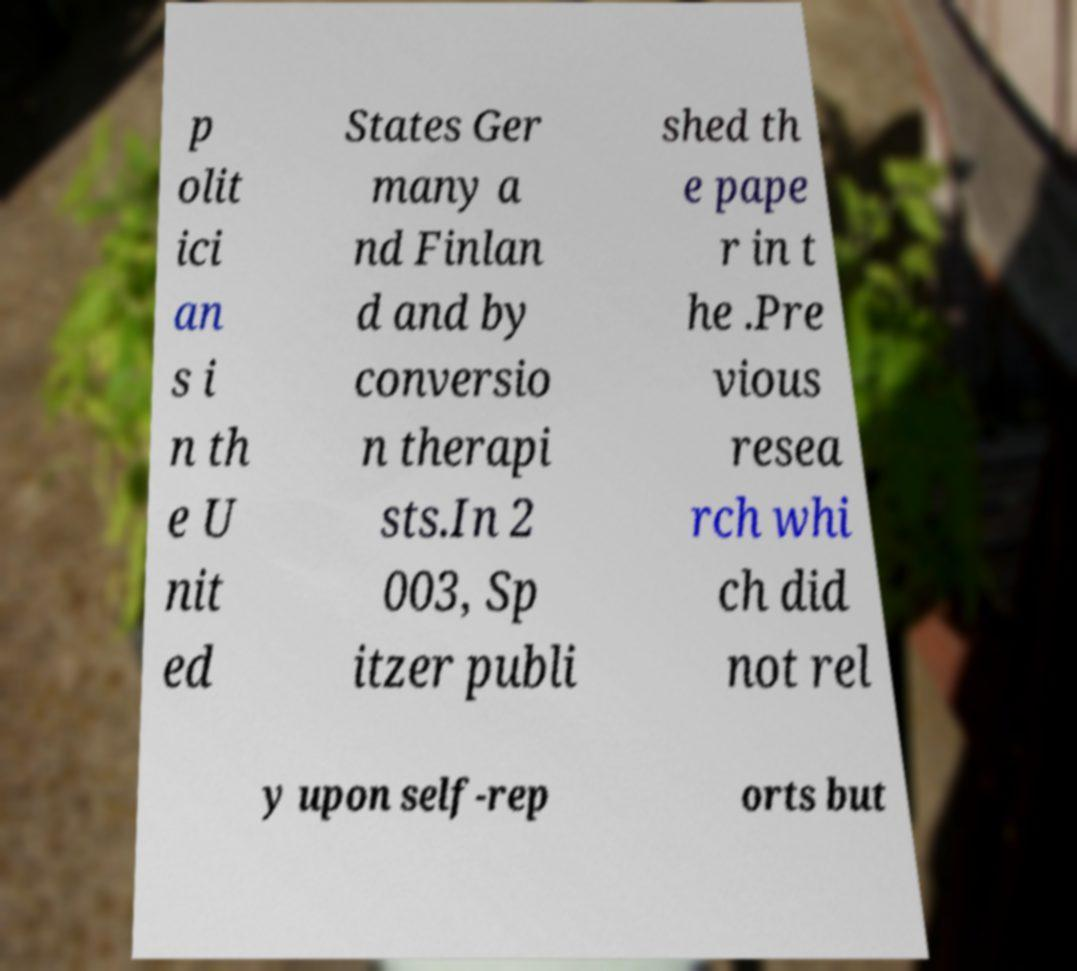Please identify and transcribe the text found in this image. p olit ici an s i n th e U nit ed States Ger many a nd Finlan d and by conversio n therapi sts.In 2 003, Sp itzer publi shed th e pape r in t he .Pre vious resea rch whi ch did not rel y upon self-rep orts but 